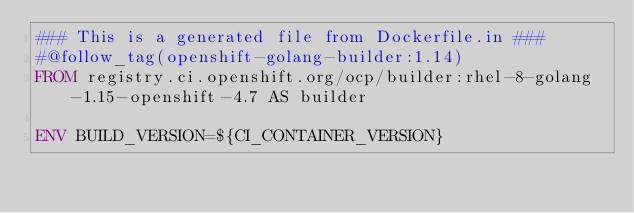Convert code to text. <code><loc_0><loc_0><loc_500><loc_500><_Dockerfile_>### This is a generated file from Dockerfile.in ###
#@follow_tag(openshift-golang-builder:1.14)
FROM registry.ci.openshift.org/ocp/builder:rhel-8-golang-1.15-openshift-4.7 AS builder

ENV BUILD_VERSION=${CI_CONTAINER_VERSION}</code> 